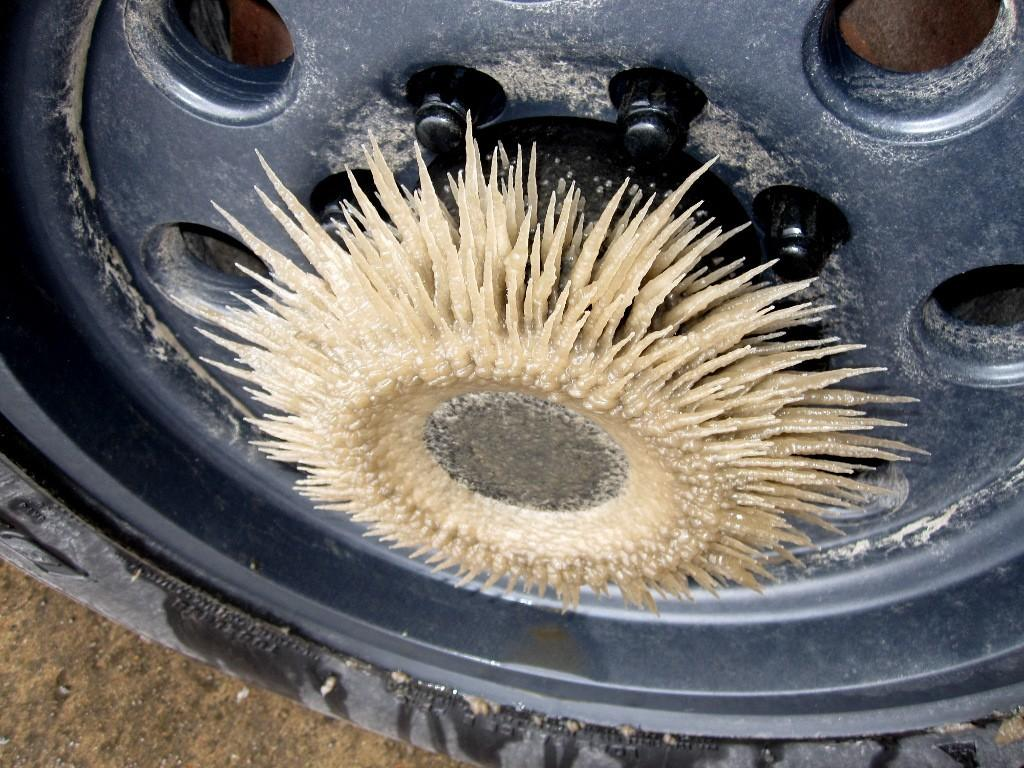What is the main object in the image? There is a wheel in the image. What color is the wheel? The wheel is black in color. Are there any additional features on the wheel? Yes, the wheel has bolts. What type of surface can be seen in the image? There is ground visible in the image. What is the shape of the object with sharp edges? The object with sharp edges is a rectangular box. What type of riddle is the wheel trying to solve in the image? There is no indication in the image that the wheel is trying to solve a riddle; it is simply a wheel with bolts. Who is the servant attending to in the image? There is no servant present in the image. 